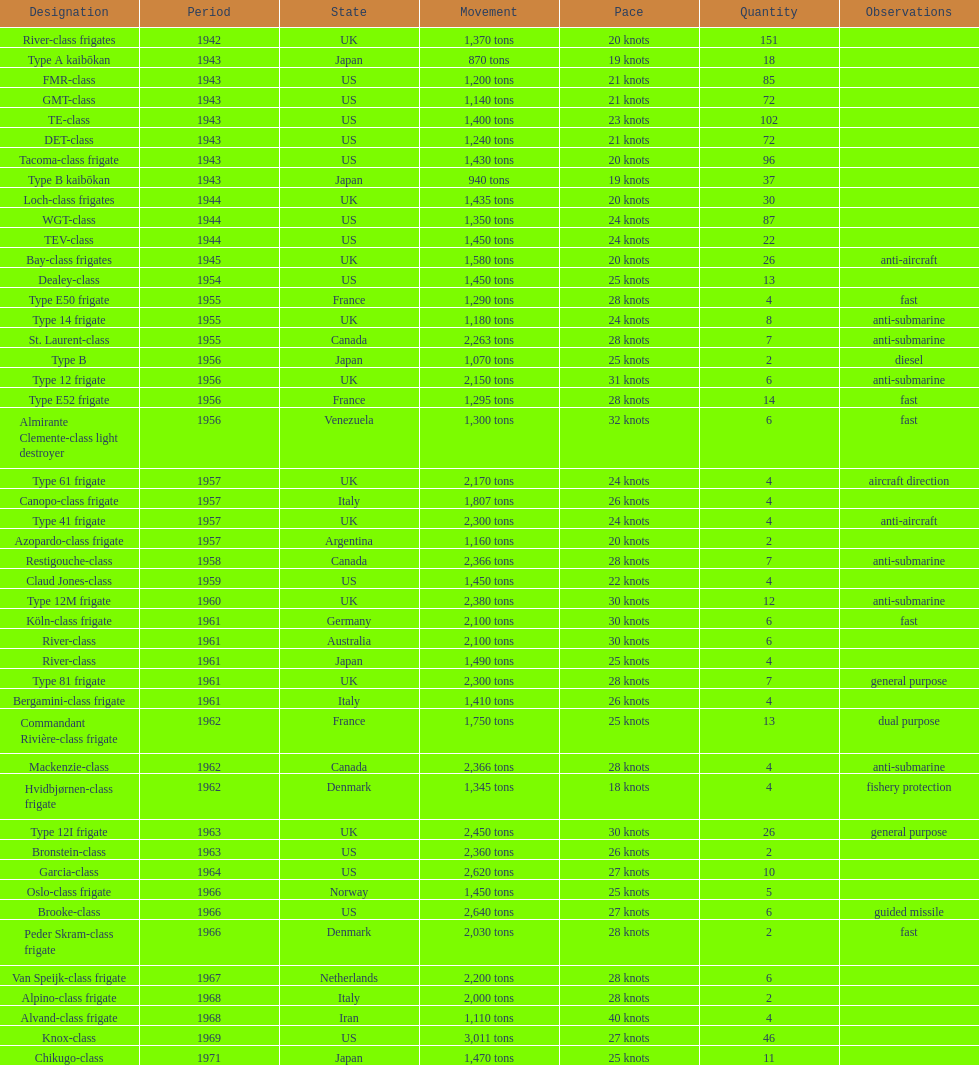How many consecutive escorts were in 1943? 7. 